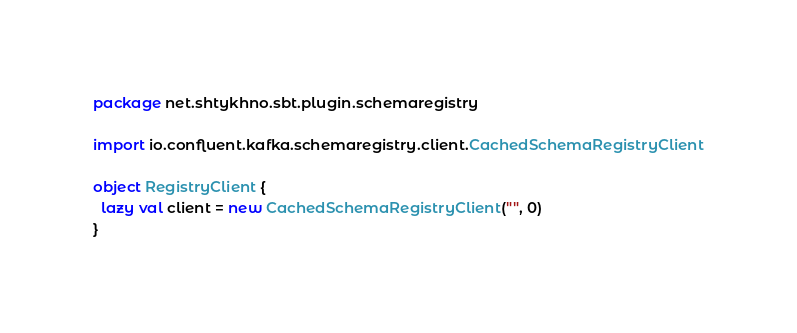Convert code to text. <code><loc_0><loc_0><loc_500><loc_500><_Scala_>package net.shtykhno.sbt.plugin.schemaregistry

import io.confluent.kafka.schemaregistry.client.CachedSchemaRegistryClient

object RegistryClient {
  lazy val client = new CachedSchemaRegistryClient("", 0)
}
</code> 